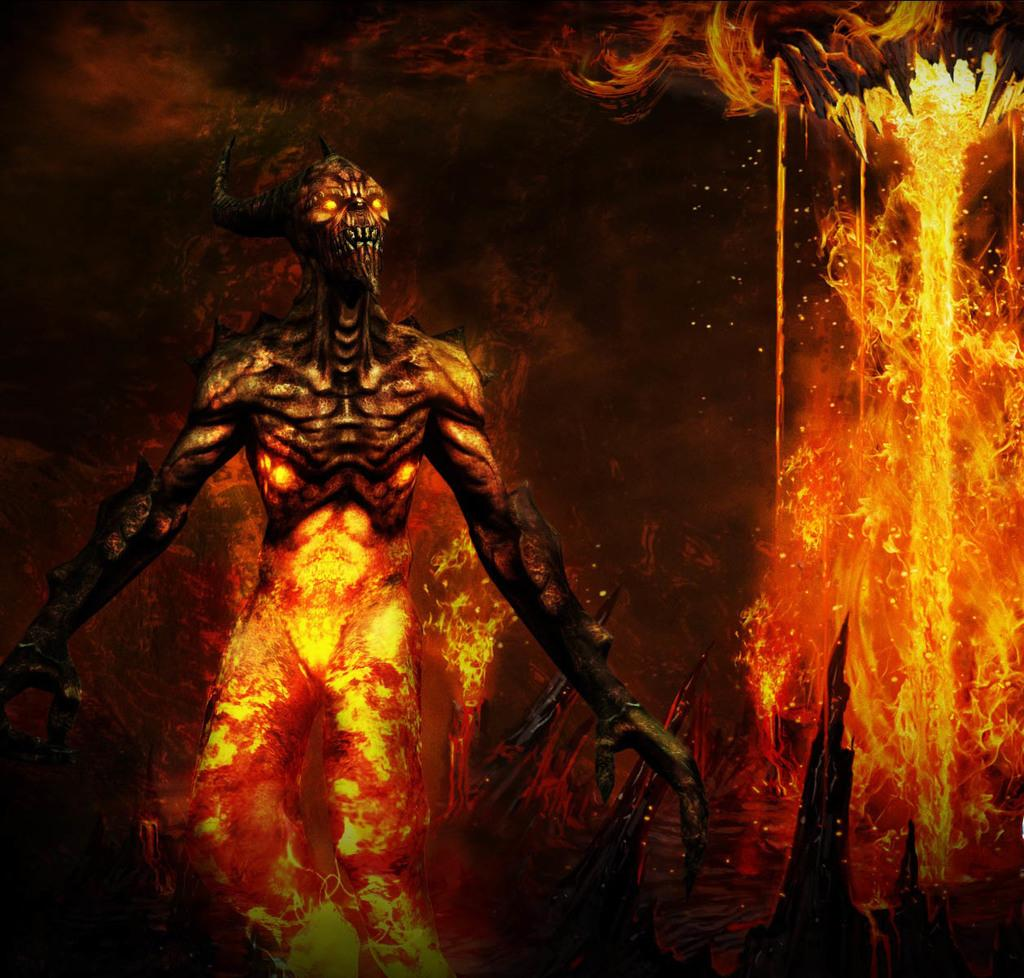What type of picture is present in the image? The image contains an animated picture. What type of fuel is being used by the animated character in the image? There is no animated character or fuel present in the image; it only contains an animated picture. 